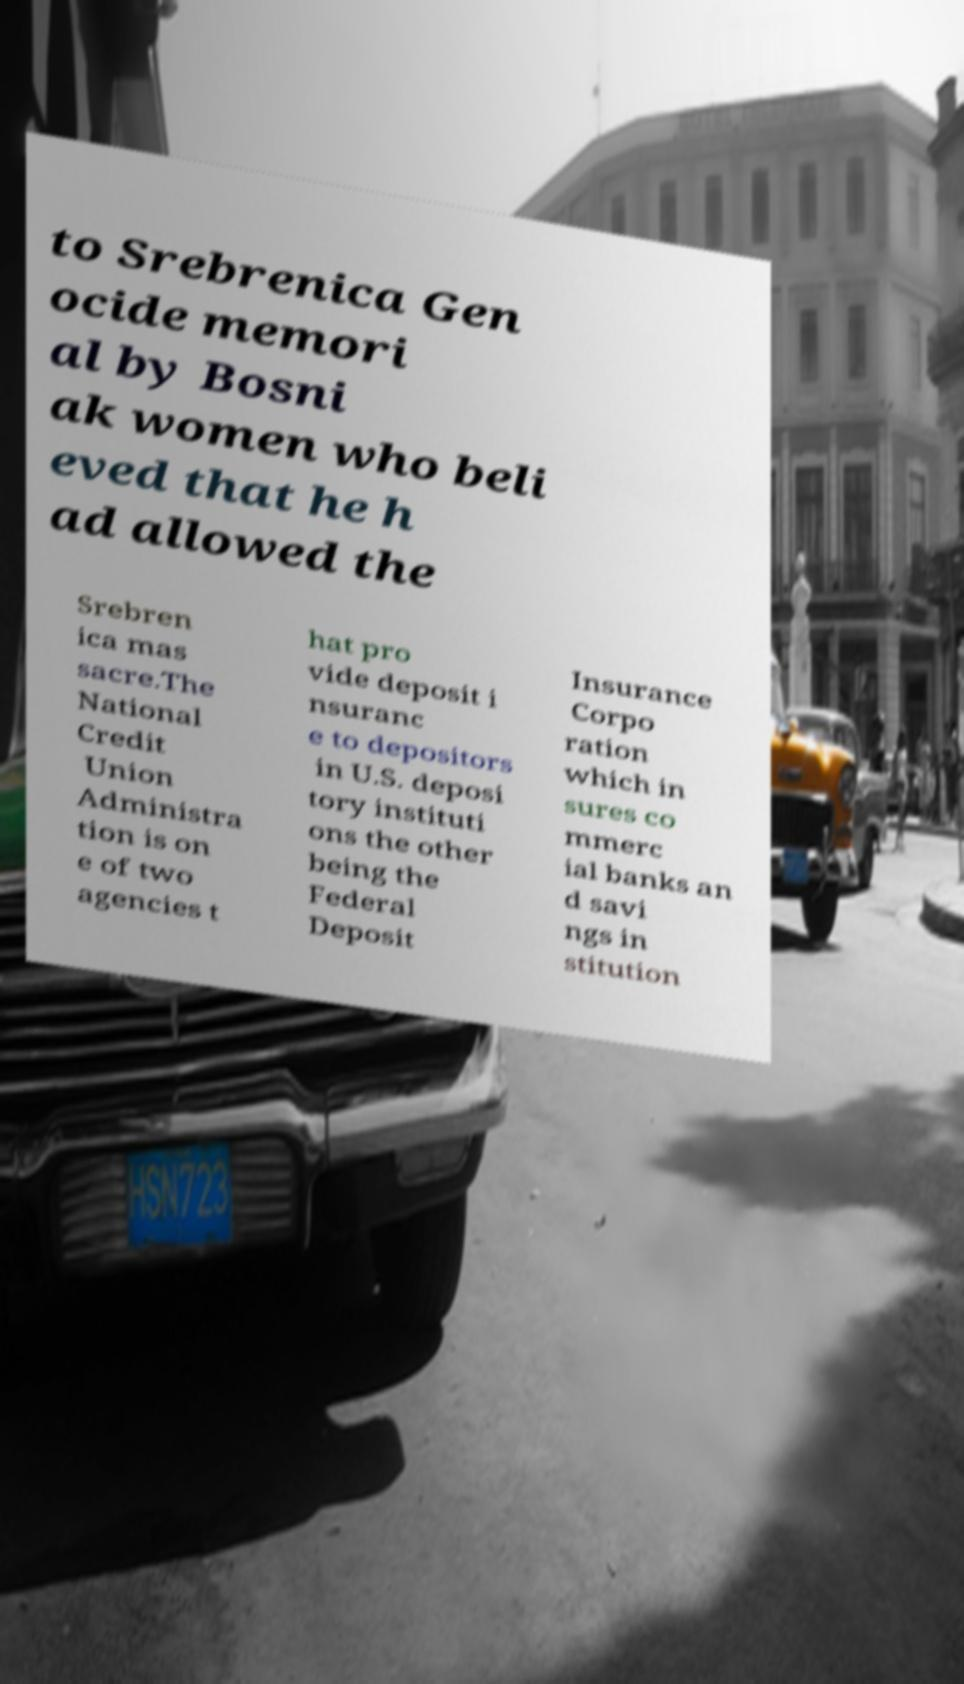Please read and relay the text visible in this image. What does it say? to Srebrenica Gen ocide memori al by Bosni ak women who beli eved that he h ad allowed the Srebren ica mas sacre.The National Credit Union Administra tion is on e of two agencies t hat pro vide deposit i nsuranc e to depositors in U.S. deposi tory instituti ons the other being the Federal Deposit Insurance Corpo ration which in sures co mmerc ial banks an d savi ngs in stitution 